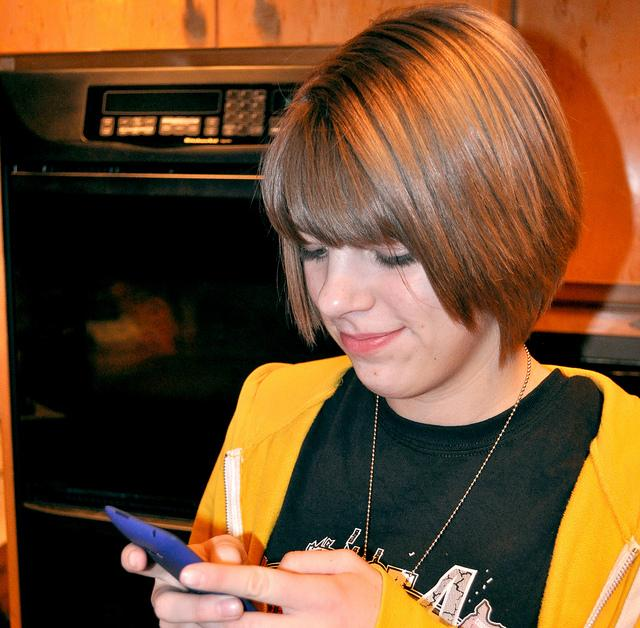What is she doing? Please explain your reasoning. using phone. The girls is texting on the phone. 